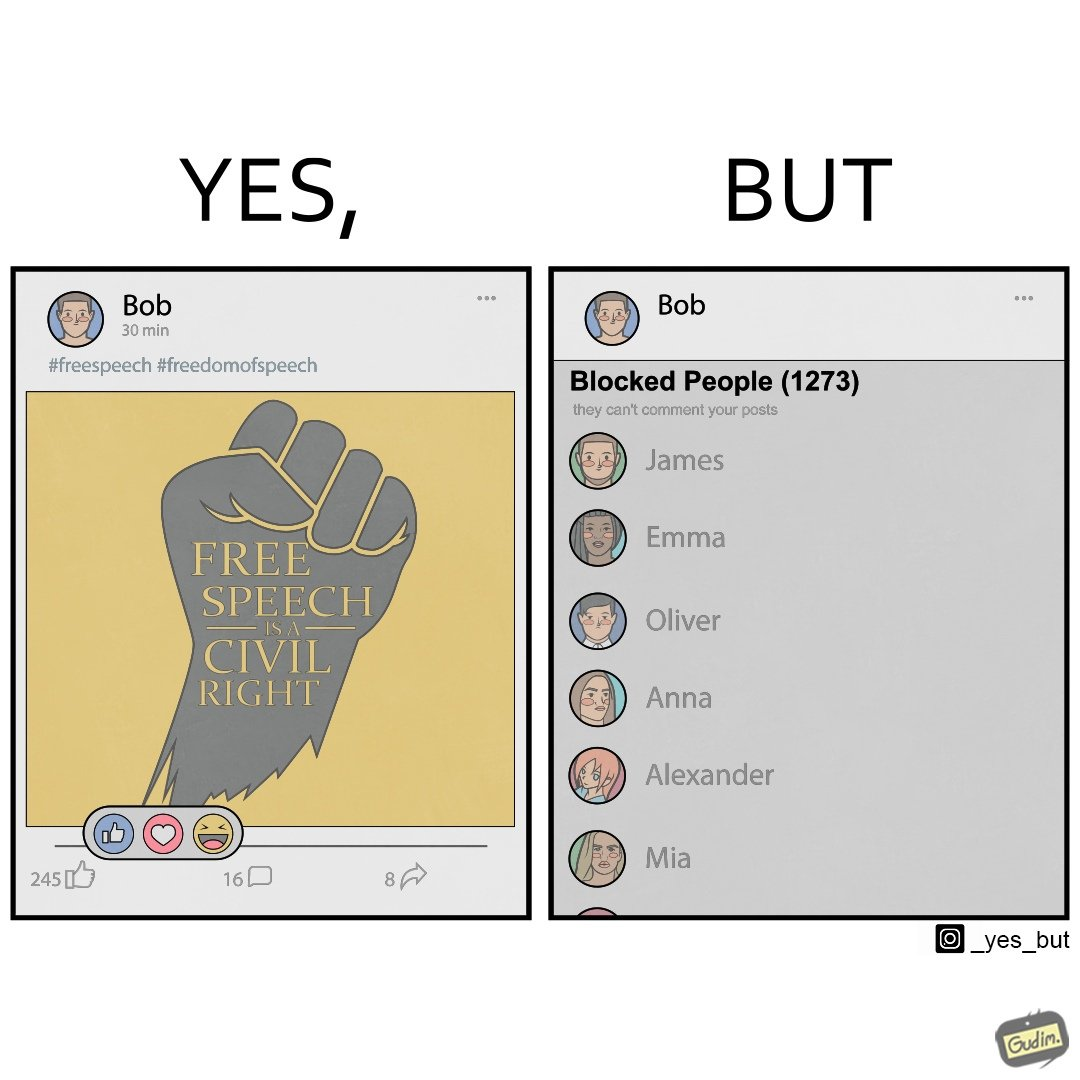What does this image depict? The images are funny since even though someone like "Bob" shows support for free speech as a civil right, he is not ready to deal with the consequences of free speech and chooses to not be spoken to by certain people. He thus blocks people from contacting him on his phone. 